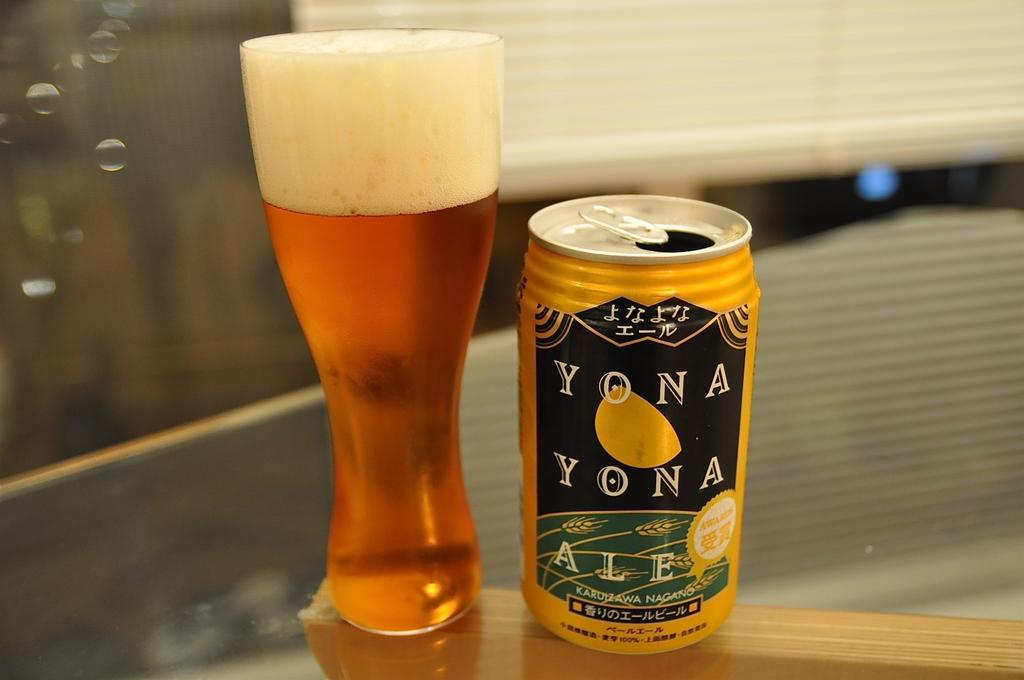<image>
Share a concise interpretation of the image provided. A black and yellow can of Yona Yona Ale stands next to a full glass of beer. 